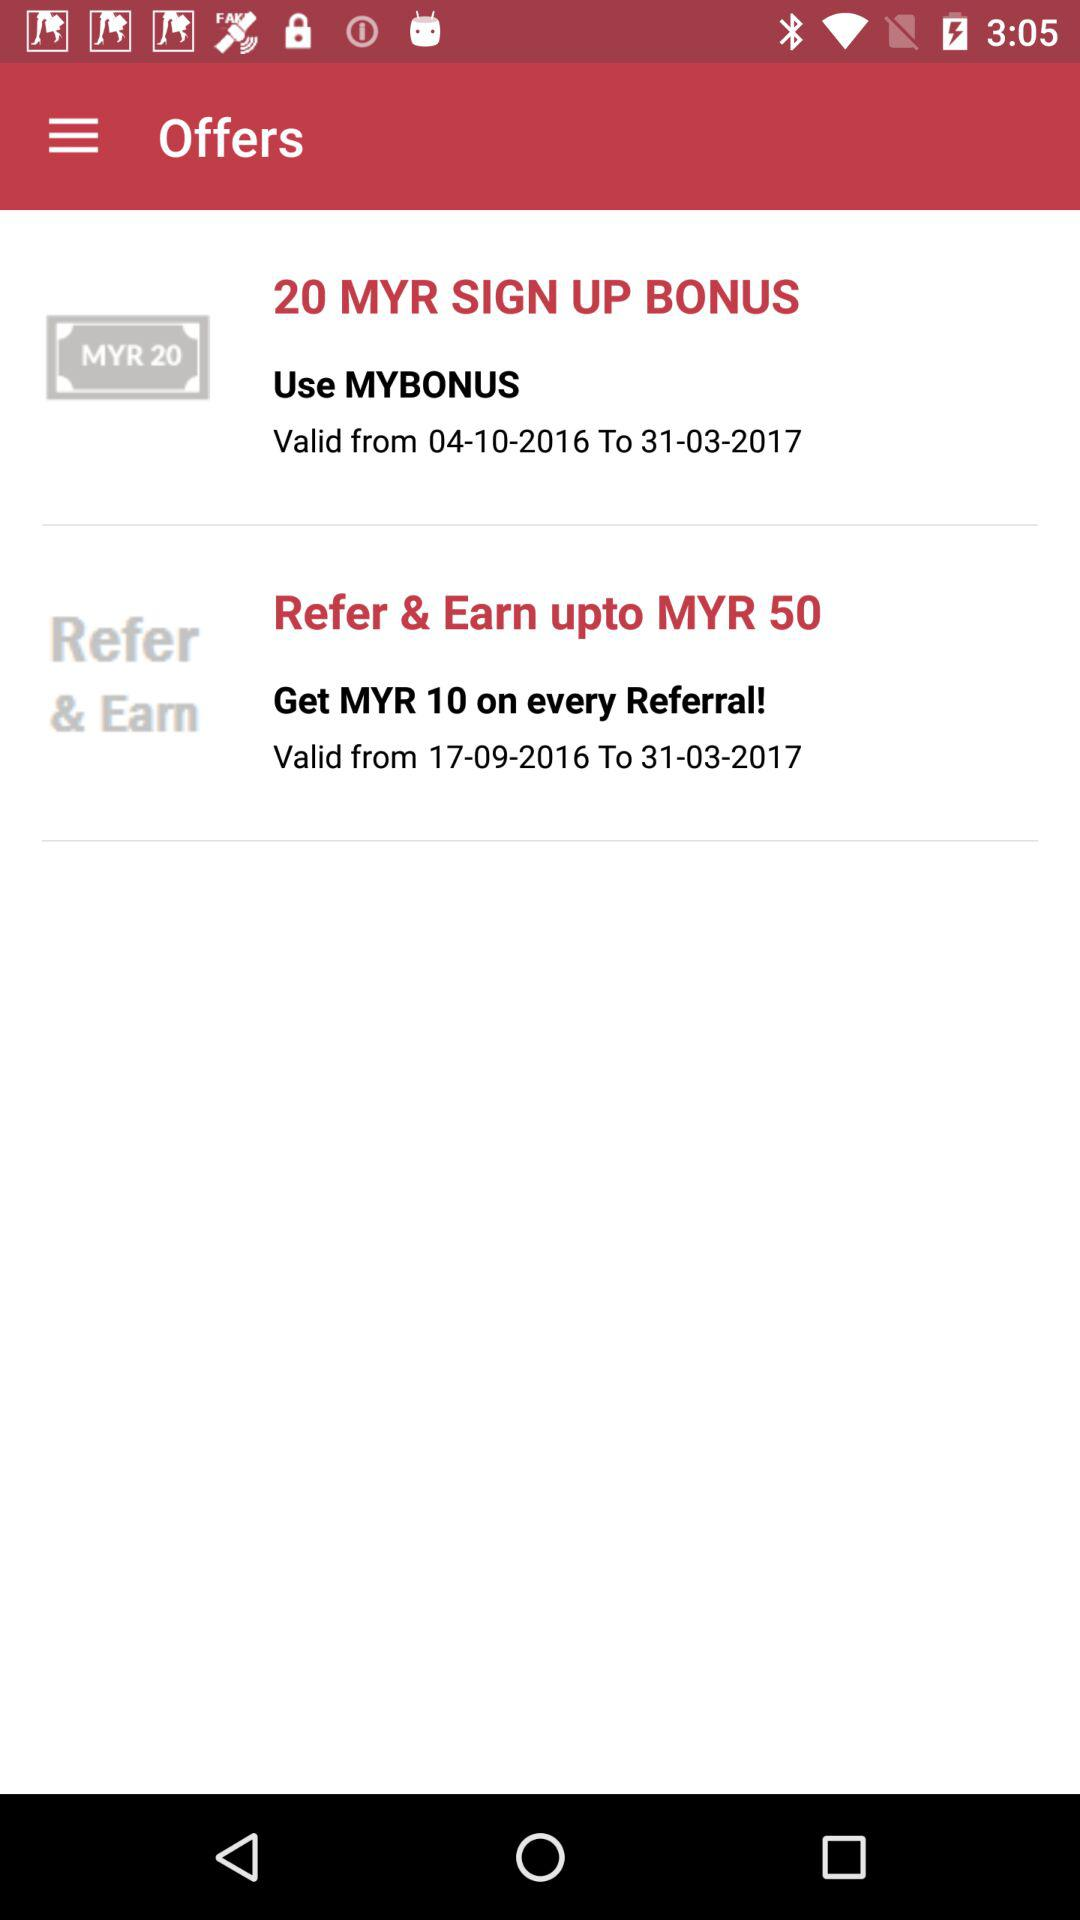How many MYR will I get on sign up? You will get 20 MYR. 